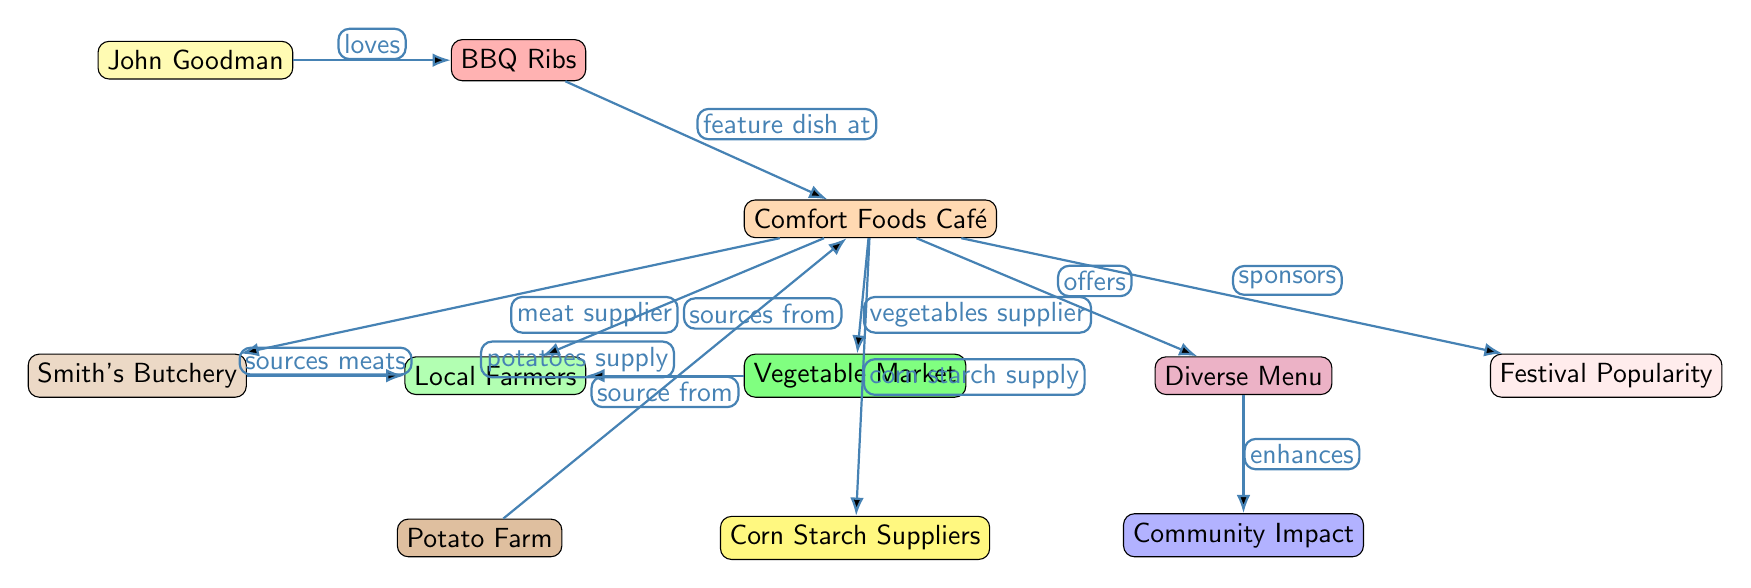What is John Goodman’s favorite dish? The diagram indicates that John Goodman loves BBQ Ribs, which is directly stated next to the connection from John Goodman to BBQ Ribs.
Answer: BBQ Ribs How many nodes are in the diagram? The diagram has a total of 10 nodes, which can be counted: John Goodman, BBQ Ribs, Comfort Foods Café, Local Farmers, Smith's Butchery, Vegetable Market, Corn Starch Suppliers, Potato Farm, Diverse Menu, Community Impact, and Festival Popularity.
Answer: 10 What does the Comfort Foods Café source from Local Farmers? The connection from Comfort Foods Café to Local Farmers states "sources from", indicating a supply relationship for ingredients at the café.
Answer: Sources from Which entity supplies potatoes to the Comfort Foods Café? According to the diagram, the connection specifies that the Potato Farm supplies potatoes to the Comfort Foods Café as directly stated in the diagram.
Answer: Potato Farm What is the relationship between Comfort Foods Café and Diverse Menu? The diagram shows that Comfort Foods Café "offers" a Diverse Menu, signifying a direct relationship where the café presents a variety of options.
Answer: Offers How does the Diverse Menu impact the Community Impact? The diagram illustrates that the Diverse Menu "enhances" Community Impact, implying that a varied menu contributes positively to community engagement or dynamics.
Answer: Enhances What do the Vegetable Market and Local Farmers have in common? Both entities have connections to Comfort Foods Café, indicating that they are part of the supply chain, thus both source ingredients for the café.
Answer: Source ingredients Which unit acts as a meat supplier to the Comfort Foods Café? The diagram clearly depicts Smith's Butchery as the meat supplier to the Comfort Foods Café through a direct connection labeled "meat supplier".
Answer: Smith's Butchery How does the Comfort Foods Café support Festival Popularity? The connection labeled "sponsors" between Comfort Foods Café and Festival Popularity shows that the café contributes to the popularity of local festivals.
Answer: Sponsors 